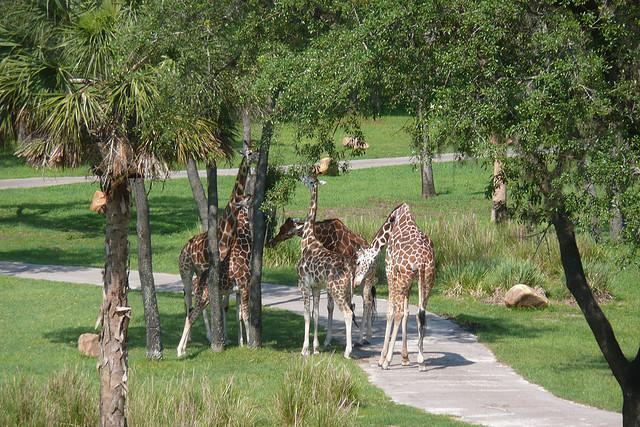How many animals are in this picture?
Give a very brief answer. 5. How many giraffe are standing side by side?
Give a very brief answer. 4. How many giraffes are there?
Give a very brief answer. 5. 